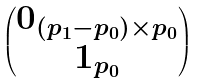Convert formula to latex. <formula><loc_0><loc_0><loc_500><loc_500>\begin{pmatrix} { 0 } _ { ( p _ { 1 } - p _ { 0 } ) \times p _ { 0 } } \\ { 1 } _ { p _ { 0 } } \end{pmatrix}</formula> 